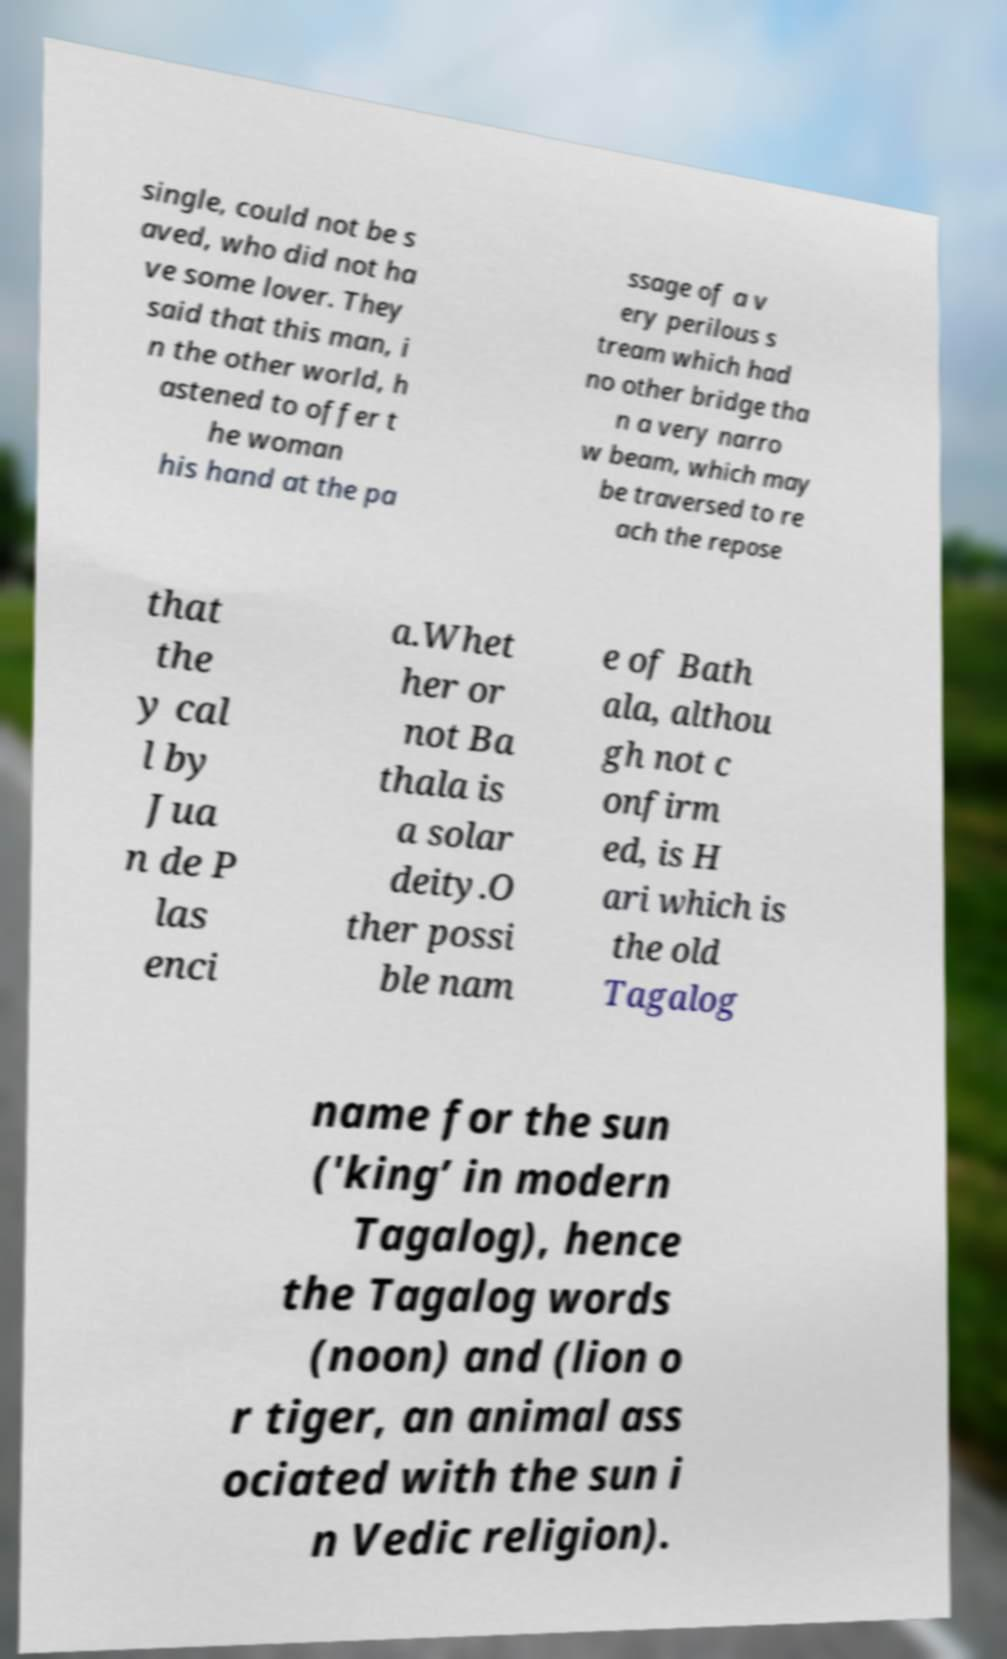There's text embedded in this image that I need extracted. Can you transcribe it verbatim? single, could not be s aved, who did not ha ve some lover. They said that this man, i n the other world, h astened to offer t he woman his hand at the pa ssage of a v ery perilous s tream which had no other bridge tha n a very narro w beam, which may be traversed to re ach the repose that the y cal l by Jua n de P las enci a.Whet her or not Ba thala is a solar deity.O ther possi ble nam e of Bath ala, althou gh not c onfirm ed, is H ari which is the old Tagalog name for the sun ('king’ in modern Tagalog), hence the Tagalog words (noon) and (lion o r tiger, an animal ass ociated with the sun i n Vedic religion). 